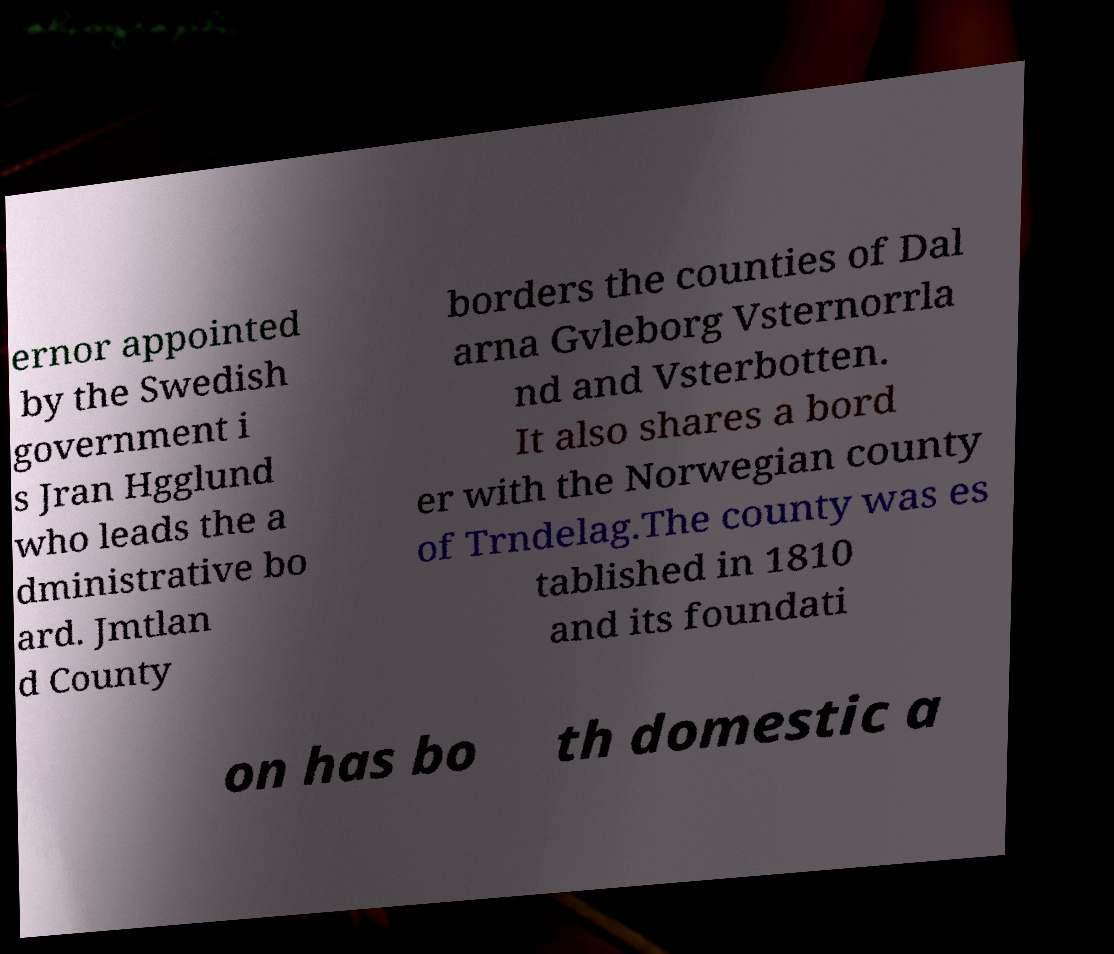What messages or text are displayed in this image? I need them in a readable, typed format. ernor appointed by the Swedish government i s Jran Hgglund who leads the a dministrative bo ard. Jmtlan d County borders the counties of Dal arna Gvleborg Vsternorrla nd and Vsterbotten. It also shares a bord er with the Norwegian county of Trndelag.The county was es tablished in 1810 and its foundati on has bo th domestic a 